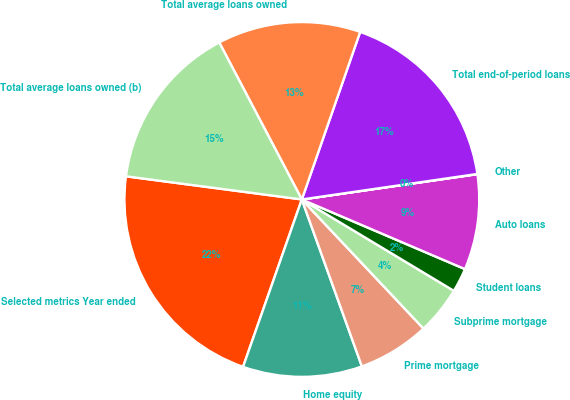Convert chart to OTSL. <chart><loc_0><loc_0><loc_500><loc_500><pie_chart><fcel>Selected metrics Year ended<fcel>Home equity<fcel>Prime mortgage<fcel>Subprime mortgage<fcel>Student loans<fcel>Auto loans<fcel>Other<fcel>Total end-of-period loans<fcel>Total average loans owned<fcel>Total average loans owned (b)<nl><fcel>21.71%<fcel>10.87%<fcel>6.53%<fcel>4.36%<fcel>2.19%<fcel>8.7%<fcel>0.02%<fcel>17.37%<fcel>13.04%<fcel>15.21%<nl></chart> 